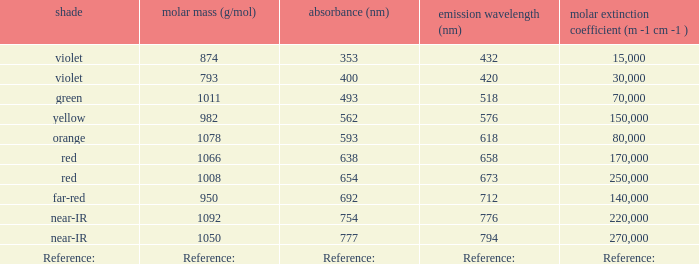What is the Absorbtion (in nanometers) of the color Orange? 593.0. 